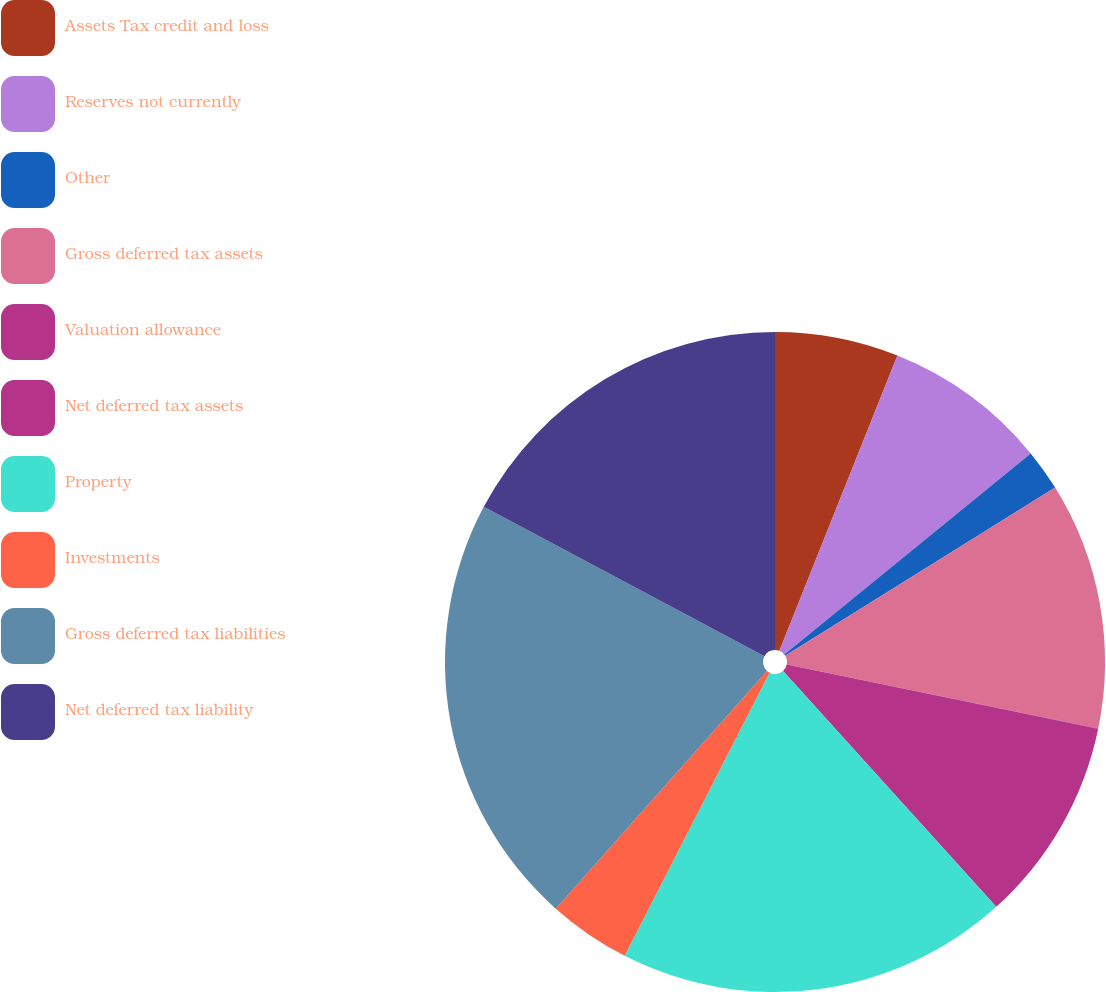Convert chart. <chart><loc_0><loc_0><loc_500><loc_500><pie_chart><fcel>Assets Tax credit and loss<fcel>Reserves not currently<fcel>Other<fcel>Gross deferred tax assets<fcel>Valuation allowance<fcel>Net deferred tax assets<fcel>Property<fcel>Investments<fcel>Gross deferred tax liabilities<fcel>Net deferred tax liability<nl><fcel>6.05%<fcel>8.06%<fcel>2.03%<fcel>12.08%<fcel>0.02%<fcel>10.07%<fcel>19.22%<fcel>4.04%<fcel>21.23%<fcel>17.21%<nl></chart> 